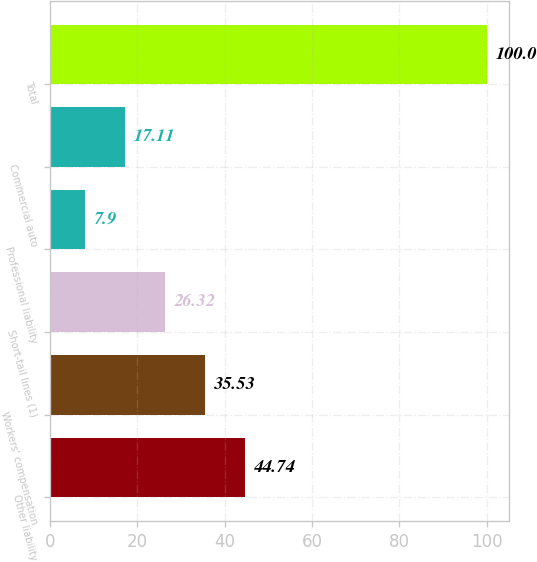<chart> <loc_0><loc_0><loc_500><loc_500><bar_chart><fcel>Other liability<fcel>Workers' compensation<fcel>Short-tail lines (1)<fcel>Professional liability<fcel>Commercial auto<fcel>Total<nl><fcel>44.74<fcel>35.53<fcel>26.32<fcel>7.9<fcel>17.11<fcel>100<nl></chart> 